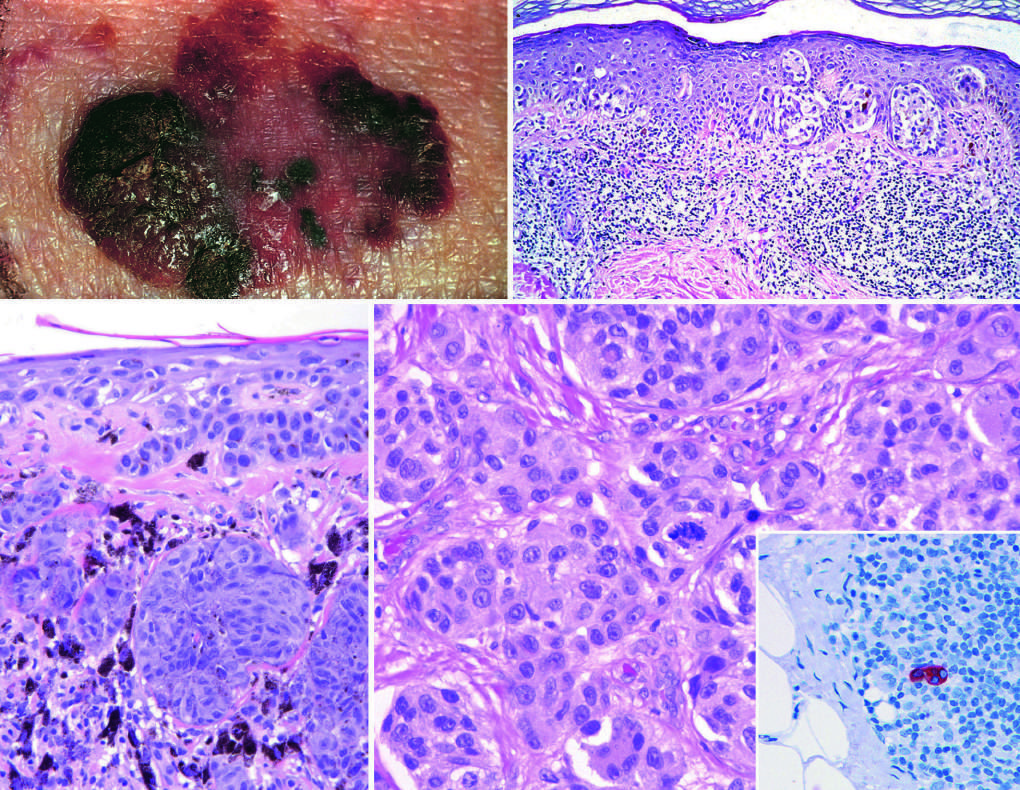what tend to be larger than nevi, with irregular contours and variable pigmentation?
Answer the question using a single word or phrase. Lesions 